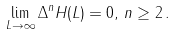<formula> <loc_0><loc_0><loc_500><loc_500>\lim _ { L \rightarrow \infty } \Delta ^ { n } H ( L ) = 0 , \, n \geq 2 \, .</formula> 